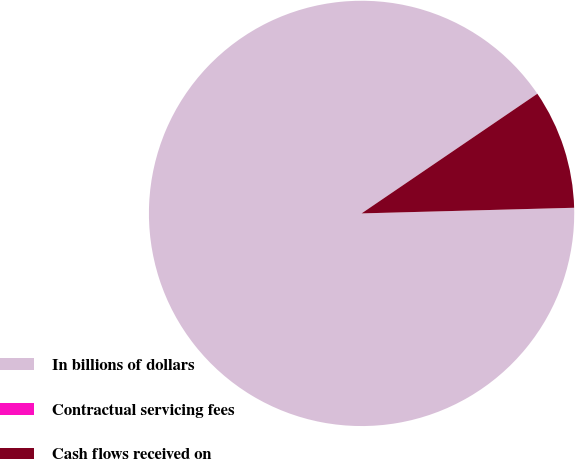Convert chart to OTSL. <chart><loc_0><loc_0><loc_500><loc_500><pie_chart><fcel>In billions of dollars<fcel>Contractual servicing fees<fcel>Cash flows received on<nl><fcel>90.9%<fcel>0.0%<fcel>9.09%<nl></chart> 